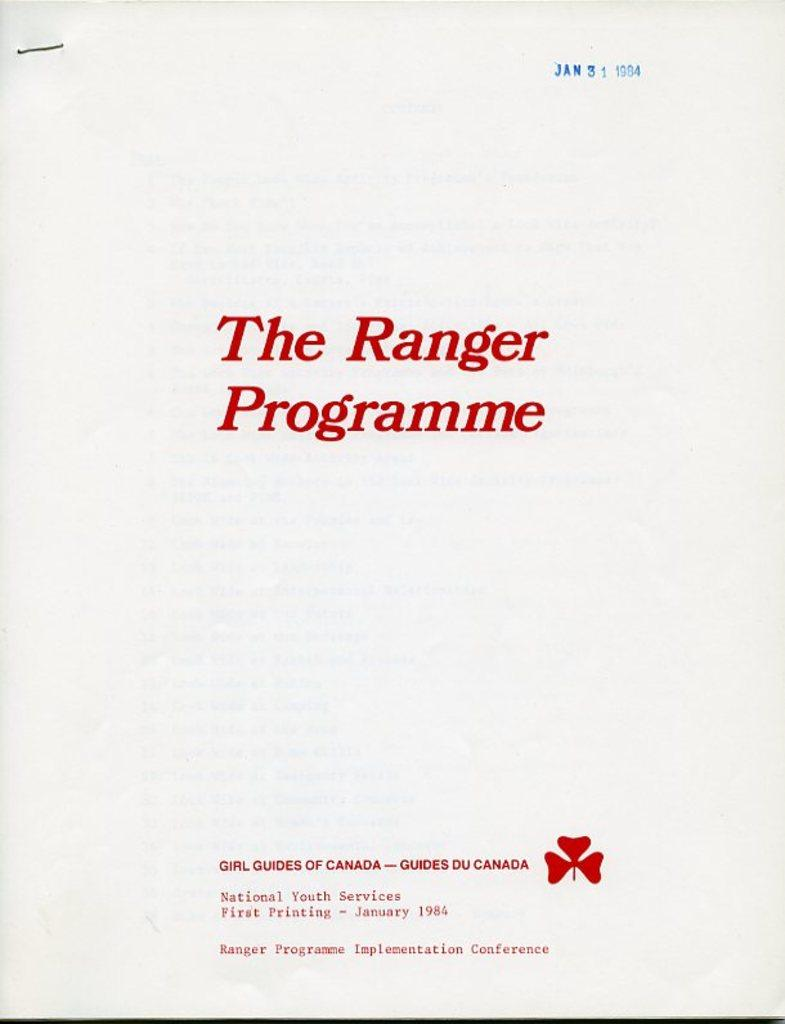<image>
Present a compact description of the photo's key features. a paper that has The Ranger Program written on it 